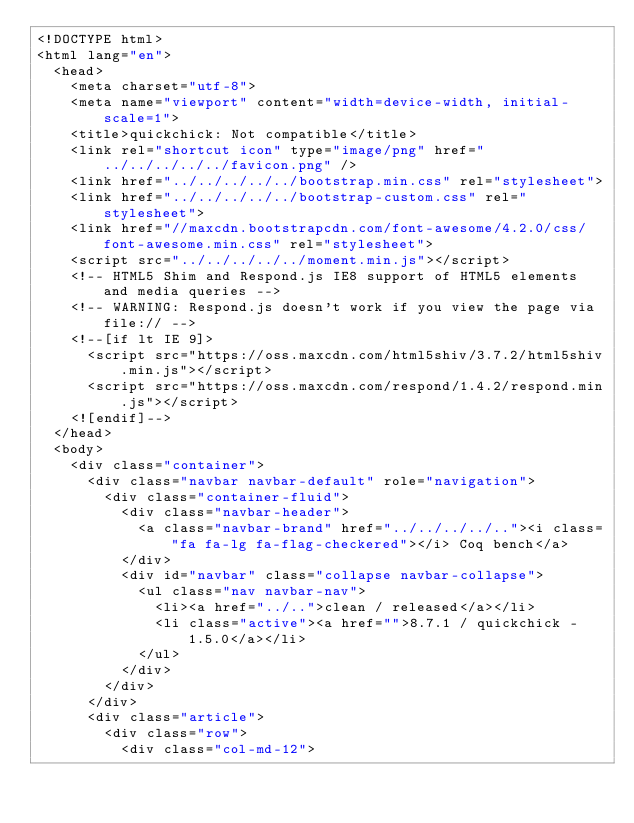<code> <loc_0><loc_0><loc_500><loc_500><_HTML_><!DOCTYPE html>
<html lang="en">
  <head>
    <meta charset="utf-8">
    <meta name="viewport" content="width=device-width, initial-scale=1">
    <title>quickchick: Not compatible</title>
    <link rel="shortcut icon" type="image/png" href="../../../../../favicon.png" />
    <link href="../../../../../bootstrap.min.css" rel="stylesheet">
    <link href="../../../../../bootstrap-custom.css" rel="stylesheet">
    <link href="//maxcdn.bootstrapcdn.com/font-awesome/4.2.0/css/font-awesome.min.css" rel="stylesheet">
    <script src="../../../../../moment.min.js"></script>
    <!-- HTML5 Shim and Respond.js IE8 support of HTML5 elements and media queries -->
    <!-- WARNING: Respond.js doesn't work if you view the page via file:// -->
    <!--[if lt IE 9]>
      <script src="https://oss.maxcdn.com/html5shiv/3.7.2/html5shiv.min.js"></script>
      <script src="https://oss.maxcdn.com/respond/1.4.2/respond.min.js"></script>
    <![endif]-->
  </head>
  <body>
    <div class="container">
      <div class="navbar navbar-default" role="navigation">
        <div class="container-fluid">
          <div class="navbar-header">
            <a class="navbar-brand" href="../../../../.."><i class="fa fa-lg fa-flag-checkered"></i> Coq bench</a>
          </div>
          <div id="navbar" class="collapse navbar-collapse">
            <ul class="nav navbar-nav">
              <li><a href="../..">clean / released</a></li>
              <li class="active"><a href="">8.7.1 / quickchick - 1.5.0</a></li>
            </ul>
          </div>
        </div>
      </div>
      <div class="article">
        <div class="row">
          <div class="col-md-12"></code> 